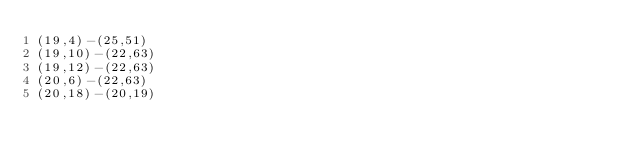Convert code to text. <code><loc_0><loc_0><loc_500><loc_500><_OCaml_>(19,4)-(25,51)
(19,10)-(22,63)
(19,12)-(22,63)
(20,6)-(22,63)
(20,18)-(20,19)</code> 